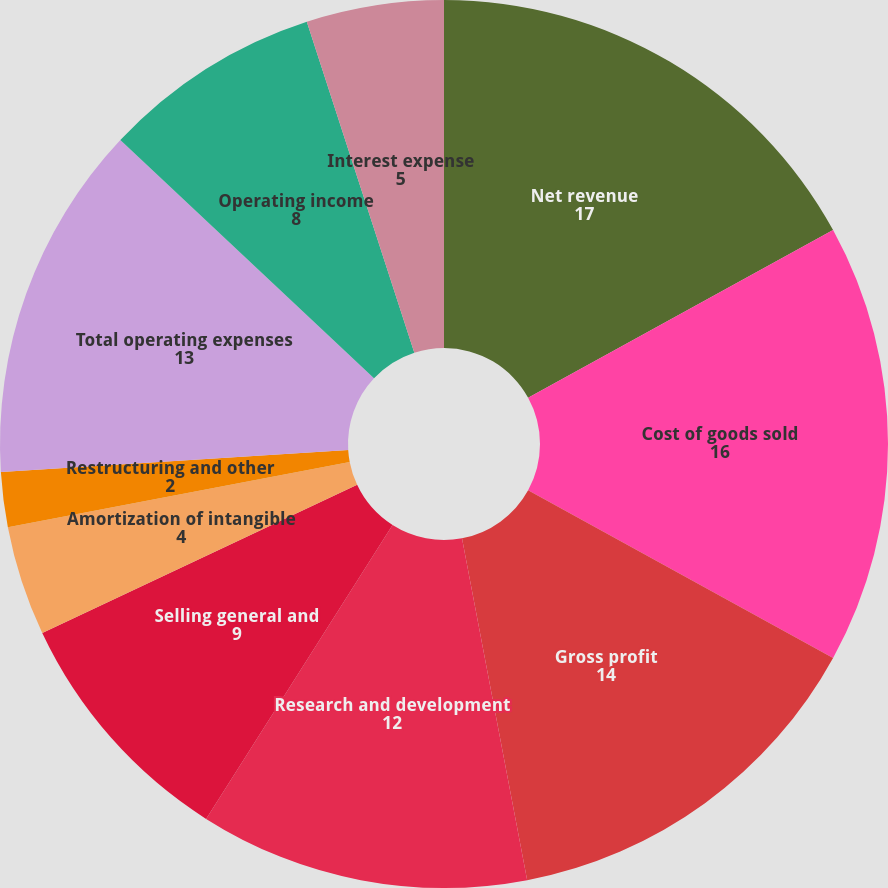Convert chart to OTSL. <chart><loc_0><loc_0><loc_500><loc_500><pie_chart><fcel>Net revenue<fcel>Cost of goods sold<fcel>Gross profit<fcel>Research and development<fcel>Selling general and<fcel>Amortization of intangible<fcel>Restructuring and other<fcel>Total operating expenses<fcel>Operating income<fcel>Interest expense<nl><fcel>17.0%<fcel>16.0%<fcel>14.0%<fcel>12.0%<fcel>9.0%<fcel>4.0%<fcel>2.0%<fcel>13.0%<fcel>8.0%<fcel>5.0%<nl></chart> 